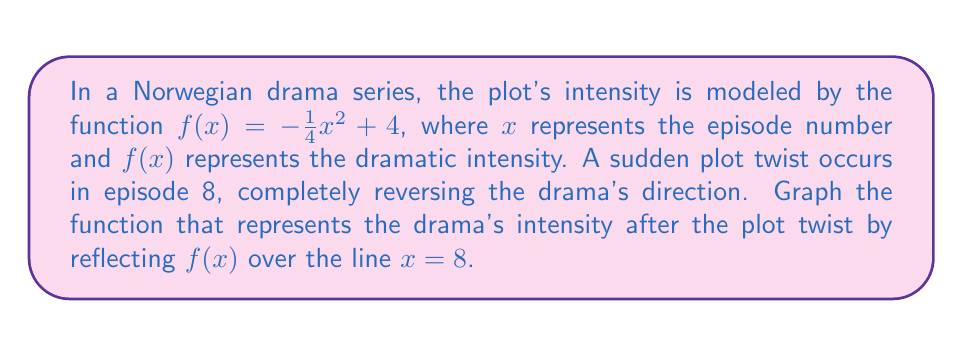Help me with this question. To reflect the function $f(x) = -\frac{1}{4}x^2 + 4$ over the line $x = 8$, we need to follow these steps:

1) The general form for reflecting a function $f(x)$ over the line $x = a$ is:
   $g(x) = f(2a - x)$

2) In this case, $a = 8$, so our new function will be:
   $g(x) = f(16 - x)$

3) Substitute this into our original function:
   $g(x) = -\frac{1}{4}(16 - x)^2 + 4$

4) Expand the squared term:
   $g(x) = -\frac{1}{4}(256 - 32x + x^2) + 4$

5) Distribute the negative fraction:
   $g(x) = -64 + 8x - \frac{1}{4}x^2 + 4$

6) Simplify:
   $g(x) = -\frac{1}{4}x^2 + 8x - 60$

This is the equation of the reflected function. To graph it:

[asy]
import graph;
size(200,200);
real f(real x) {return -1/4*x^2 + 4;}
real g(real x) {return -1/4*x^2 + 8*x - 60;}
draw(graph(f,0,16),blue);
draw(graph(g,0,16),red);
xaxis("x",0,16,arrow=Arrow);
yaxis("y",-60,10,arrow=Arrow);
label("f(x)",(-1,2),W);
label("g(x)",(16,-50),E);
draw((8,-60)--(8,10),dashed);
label("x = 8",(8,10),N);
[/asy]

The blue curve represents the original function $f(x)$, and the red curve represents the reflected function $g(x)$.
Answer: $g(x) = -\frac{1}{4}x^2 + 8x - 60$ 